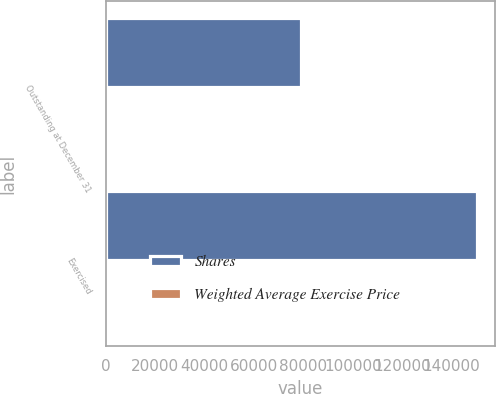<chart> <loc_0><loc_0><loc_500><loc_500><stacked_bar_chart><ecel><fcel>Outstanding at December 31<fcel>Exercised<nl><fcel>Shares<fcel>79125<fcel>150225<nl><fcel>Weighted Average Exercise Price<fcel>43.5<fcel>42.71<nl></chart> 